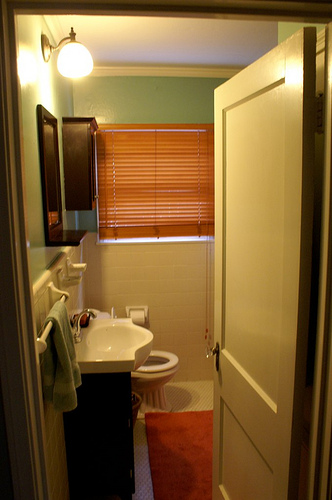Are there any items hanging on the wall? Yes, there are several items hanging on the wall. A towel rack with a towel is mounted on the left wall, and a mirror is positioned higher up on the sharegpt4v/same wall. 